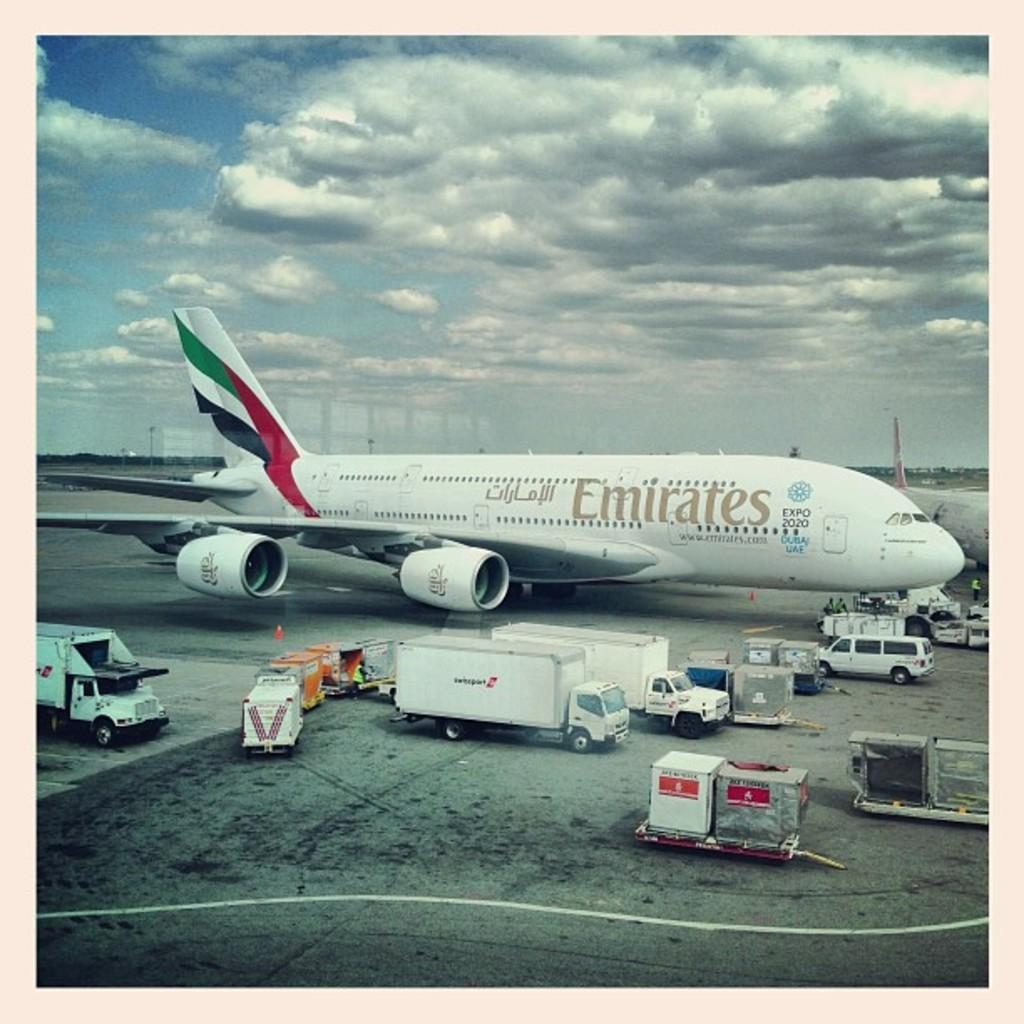What is the main subject of the image? The main subject of the image is an airplane. What part of the airplane can be seen in the image? The airplane's tail is visible in the image. What else can be seen in the image besides the airplane? There are containers and vehicles on the runway visible in the image. What is visible in the background of the image? The sky with clouds is visible in the background of the image. What type of design can be seen on the pear in the image? There is no pear present in the image, so it is not possible to determine the design on a pear. 